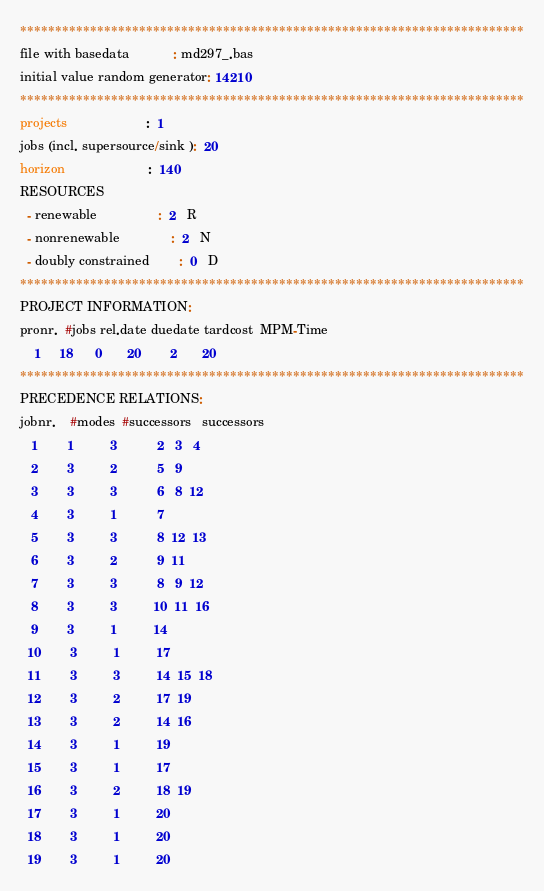<code> <loc_0><loc_0><loc_500><loc_500><_ObjectiveC_>************************************************************************
file with basedata            : md297_.bas
initial value random generator: 14210
************************************************************************
projects                      :  1
jobs (incl. supersource/sink ):  20
horizon                       :  140
RESOURCES
  - renewable                 :  2   R
  - nonrenewable              :  2   N
  - doubly constrained        :  0   D
************************************************************************
PROJECT INFORMATION:
pronr.  #jobs rel.date duedate tardcost  MPM-Time
    1     18      0       20        2       20
************************************************************************
PRECEDENCE RELATIONS:
jobnr.    #modes  #successors   successors
   1        1          3           2   3   4
   2        3          2           5   9
   3        3          3           6   8  12
   4        3          1           7
   5        3          3           8  12  13
   6        3          2           9  11
   7        3          3           8   9  12
   8        3          3          10  11  16
   9        3          1          14
  10        3          1          17
  11        3          3          14  15  18
  12        3          2          17  19
  13        3          2          14  16
  14        3          1          19
  15        3          1          17
  16        3          2          18  19
  17        3          1          20
  18        3          1          20
  19        3          1          20</code> 